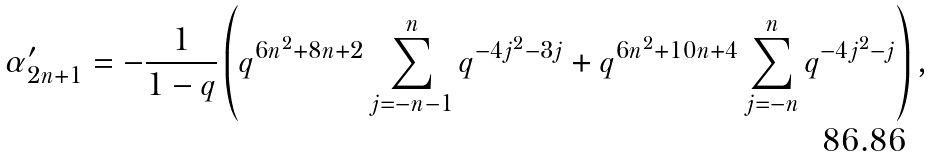Convert formula to latex. <formula><loc_0><loc_0><loc_500><loc_500>\alpha ^ { \prime } _ { 2 n + 1 } = - \frac { 1 } { 1 - q } \left ( q ^ { 6 n ^ { 2 } + 8 n + 2 } \sum _ { j = - n - 1 } ^ { n } q ^ { - 4 j ^ { 2 } - 3 j } + q ^ { 6 n ^ { 2 } + 1 0 n + 4 } \sum _ { j = - n } ^ { n } q ^ { - 4 j ^ { 2 } - j } \right ) ,</formula> 